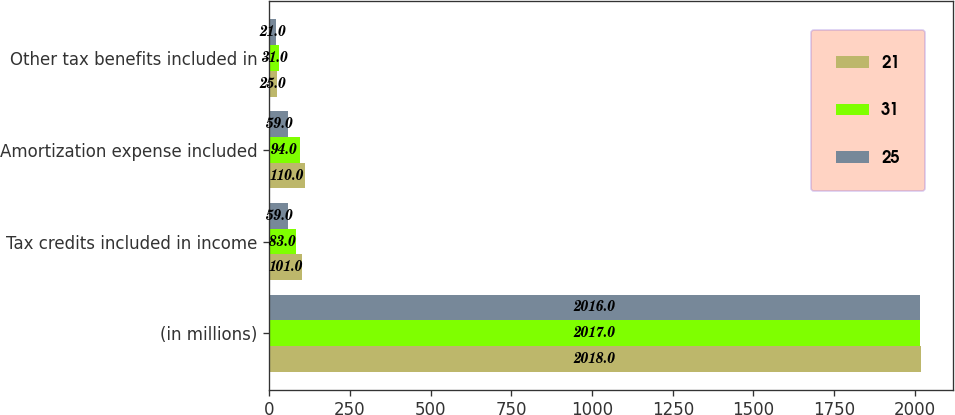Convert chart to OTSL. <chart><loc_0><loc_0><loc_500><loc_500><stacked_bar_chart><ecel><fcel>(in millions)<fcel>Tax credits included in income<fcel>Amortization expense included<fcel>Other tax benefits included in<nl><fcel>21<fcel>2018<fcel>101<fcel>110<fcel>25<nl><fcel>31<fcel>2017<fcel>83<fcel>94<fcel>31<nl><fcel>25<fcel>2016<fcel>59<fcel>59<fcel>21<nl></chart> 